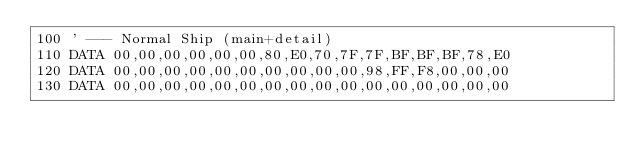<code> <loc_0><loc_0><loc_500><loc_500><_VisualBasic_>100 ' --- Normal Ship (main+detail)
110 DATA 00,00,00,00,00,00,80,E0,70,7F,7F,BF,BF,BF,78,E0
120 DATA 00,00,00,00,00,00,00,00,00,00,98,FF,F8,00,00,00
130 DATA 00,00,00,00,00,00,00,00,00,00,00,00,00,00,00,00</code> 